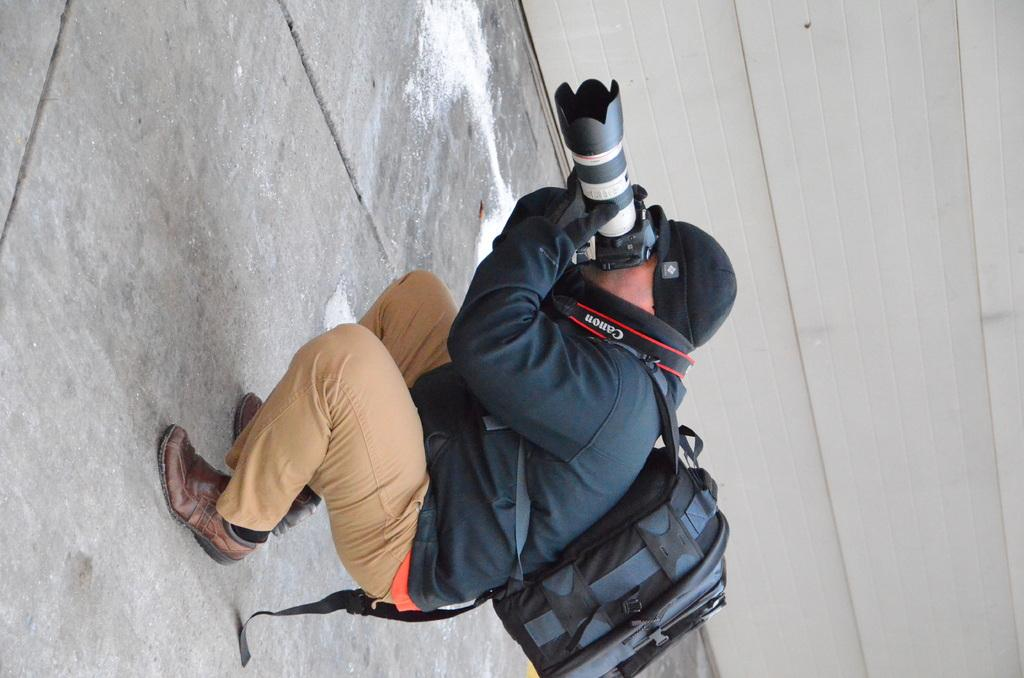What is the main subject of the image? The main subject of the image is a man. What is the man doing in the image? The man is sitting and clicking pictures. Can you describe the man's attire? The man is wearing a cap and carrying a backpack. Where is the man located in the image? The man is on a road. What can be seen in the background of the image? There is a big wall behind the man. Can you tell me how many baby jellyfish are swimming near the man in the image? There are no baby jellyfish or any jellyfish present in the image; the man is on a road with a big wall in the background. 